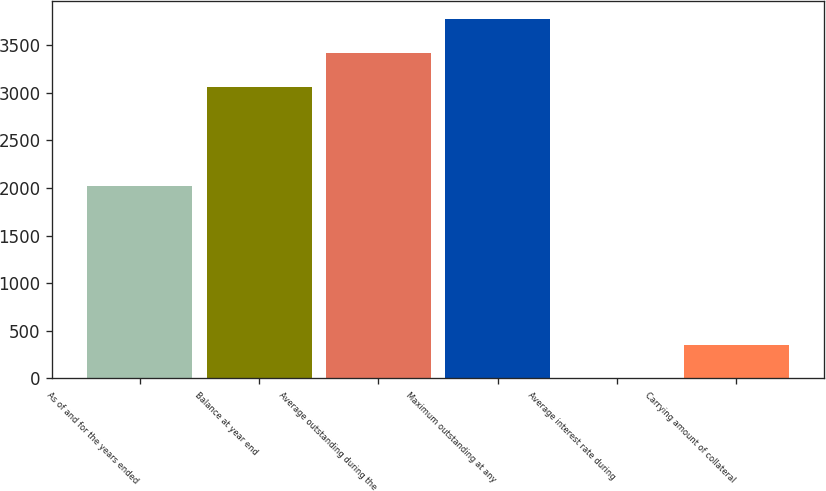<chart> <loc_0><loc_0><loc_500><loc_500><bar_chart><fcel>As of and for the years ended<fcel>Balance at year end<fcel>Average outstanding during the<fcel>Maximum outstanding at any<fcel>Average interest rate during<fcel>Carrying amount of collateral<nl><fcel>2016<fcel>3061.1<fcel>3417.29<fcel>3773.48<fcel>0.62<fcel>356.81<nl></chart> 